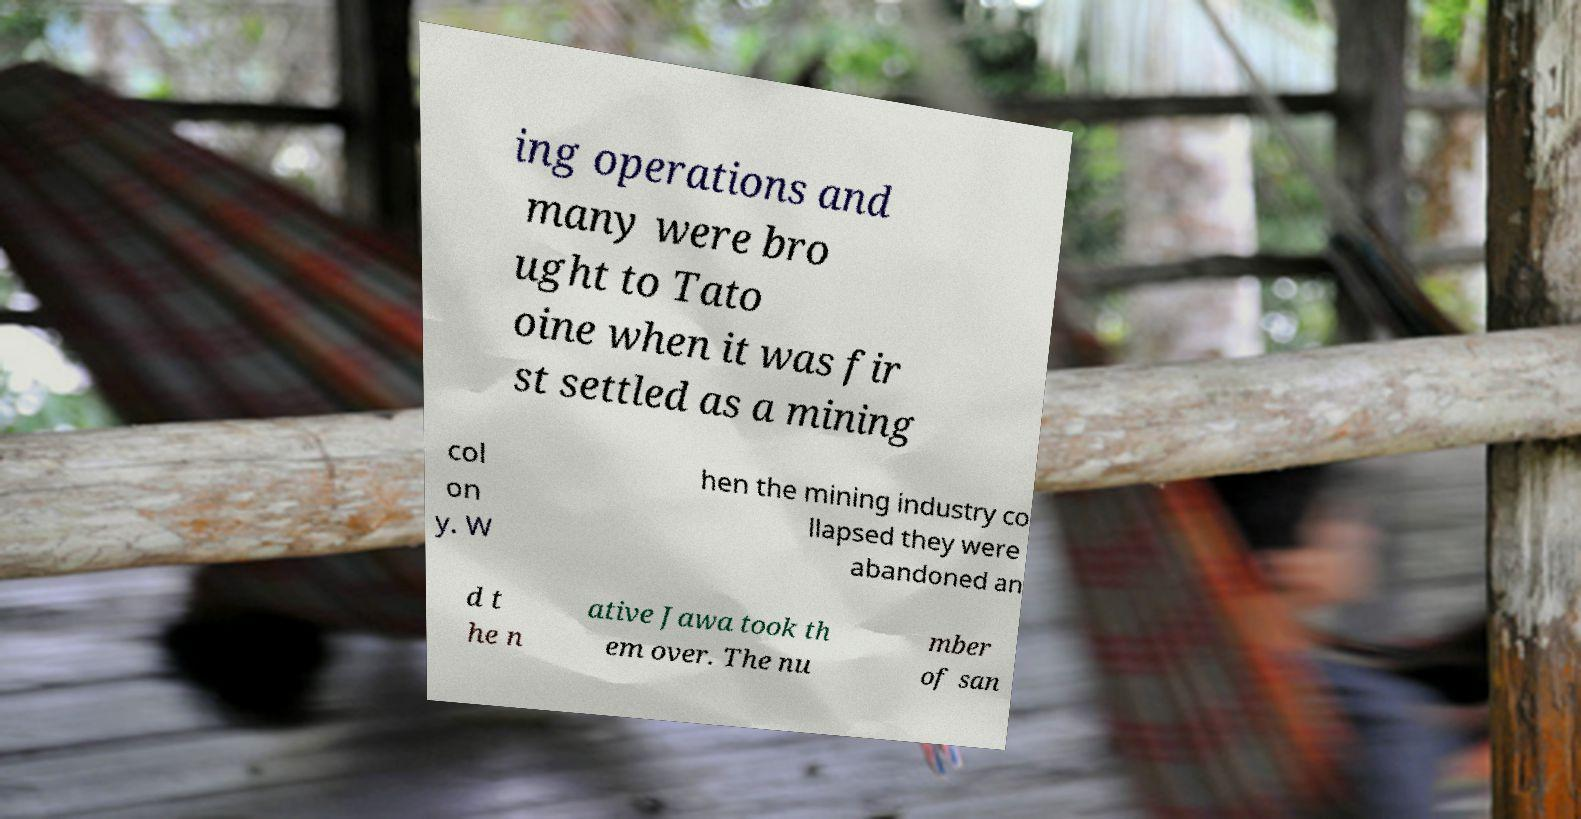Please read and relay the text visible in this image. What does it say? ing operations and many were bro ught to Tato oine when it was fir st settled as a mining col on y. W hen the mining industry co llapsed they were abandoned an d t he n ative Jawa took th em over. The nu mber of san 